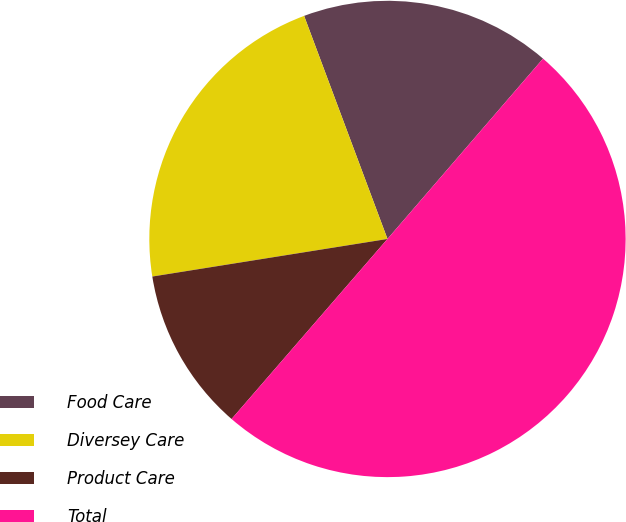<chart> <loc_0><loc_0><loc_500><loc_500><pie_chart><fcel>Food Care<fcel>Diversey Care<fcel>Product Care<fcel>Total<nl><fcel>17.02%<fcel>21.83%<fcel>11.12%<fcel>50.03%<nl></chart> 